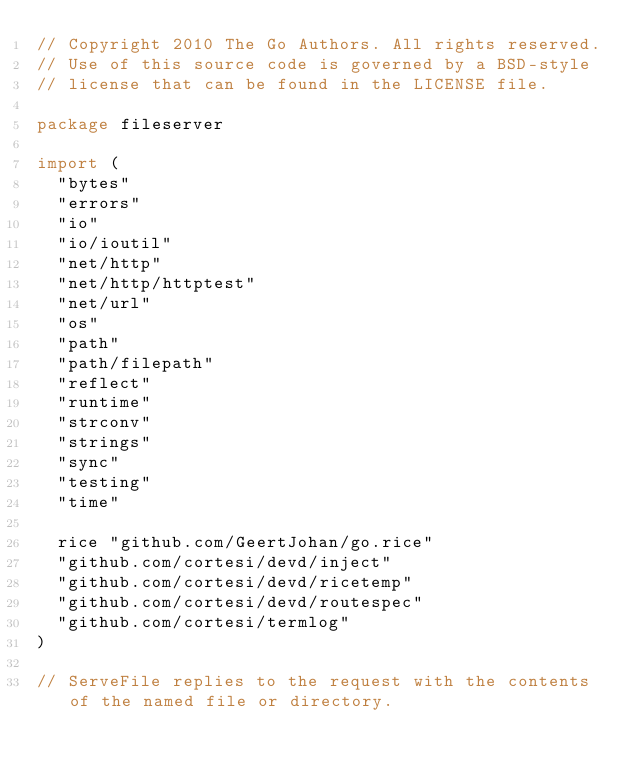<code> <loc_0><loc_0><loc_500><loc_500><_Go_>// Copyright 2010 The Go Authors. All rights reserved.
// Use of this source code is governed by a BSD-style
// license that can be found in the LICENSE file.

package fileserver

import (
	"bytes"
	"errors"
	"io"
	"io/ioutil"
	"net/http"
	"net/http/httptest"
	"net/url"
	"os"
	"path"
	"path/filepath"
	"reflect"
	"runtime"
	"strconv"
	"strings"
	"sync"
	"testing"
	"time"

	rice "github.com/GeertJohan/go.rice"
	"github.com/cortesi/devd/inject"
	"github.com/cortesi/devd/ricetemp"
	"github.com/cortesi/devd/routespec"
	"github.com/cortesi/termlog"
)

// ServeFile replies to the request with the contents of the named file or directory.</code> 